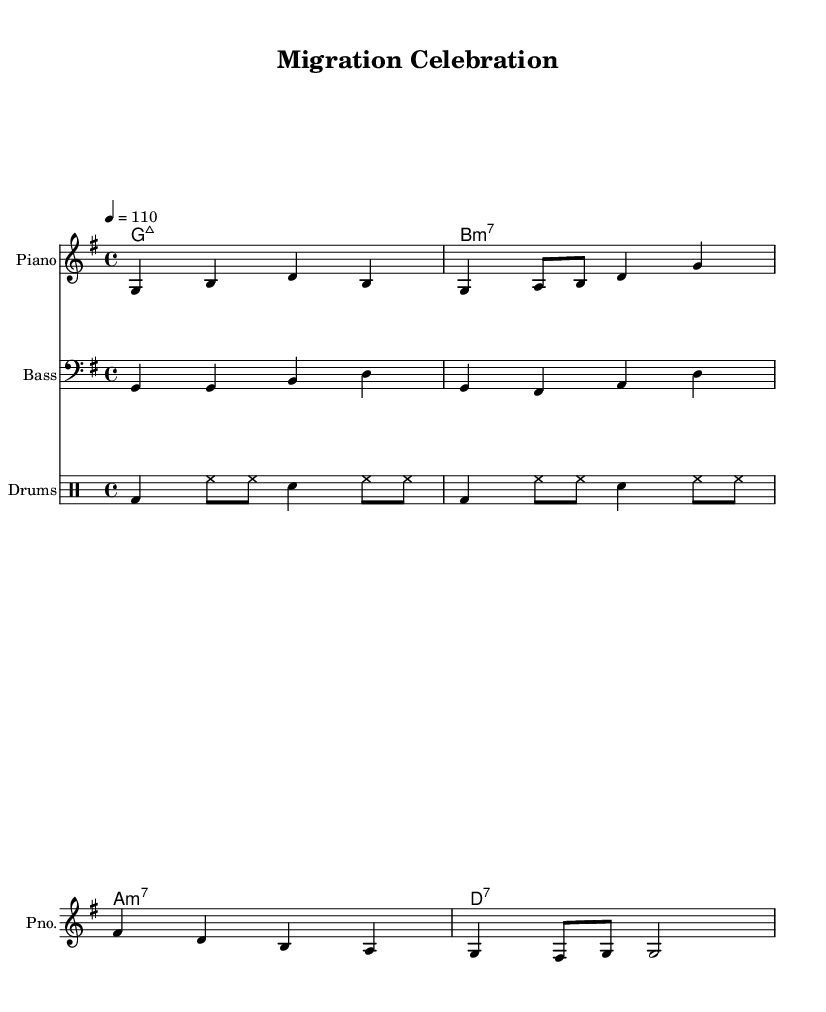What is the key signature of this music? The key signature for the piece is indicated as G major, which has one sharp (F#). This can be determined by looking at the beginning of the staff where the key signature is displayed.
Answer: G major What is the time signature of this piece? The time signature appears at the beginning of the score, shown as 4/4. This means there are four beats in each measure, with the quarter note receiving one beat.
Answer: 4/4 What is the tempo marking for this piece? The tempo marking is found above the staff, indicating a speed of 110 beats per minute (bpm). This information guides the performer regarding how quickly to play the piece.
Answer: 110 What instruments are used in this arrangement? The score includes parts for Piano, Bass, and Drums, which are explicitly labeled at the beginning of each staff. This indicates the instrumentation for the performance.
Answer: Piano, Bass, Drums Which chord follows the D7 chord in the progression? The chord progression can be analyzed from the chord names indicated in the chord mode. The chord D7 is followed by G major 7, as found in the progression sequence.
Answer: G major 7 How many measures are present in the melody section? The melody section can be counted measure by measure. By breaking it down, there are a total of 4 measures visible in the specified melody notation.
Answer: 4 What lyrical theme is presented in the verse? The lyrics present a theme of successfully upgrading systems without complications, which can be inferred from the words written under the melody notes.
Answer: Successful upgrades 